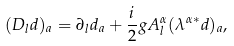Convert formula to latex. <formula><loc_0><loc_0><loc_500><loc_500>( D _ { l } { d } ) _ { a } = \partial _ { l } { d } _ { a } + \frac { i } { 2 } g A _ { l } ^ { \alpha } ( \lambda ^ { \alpha * } { d } ) _ { a } ,</formula> 